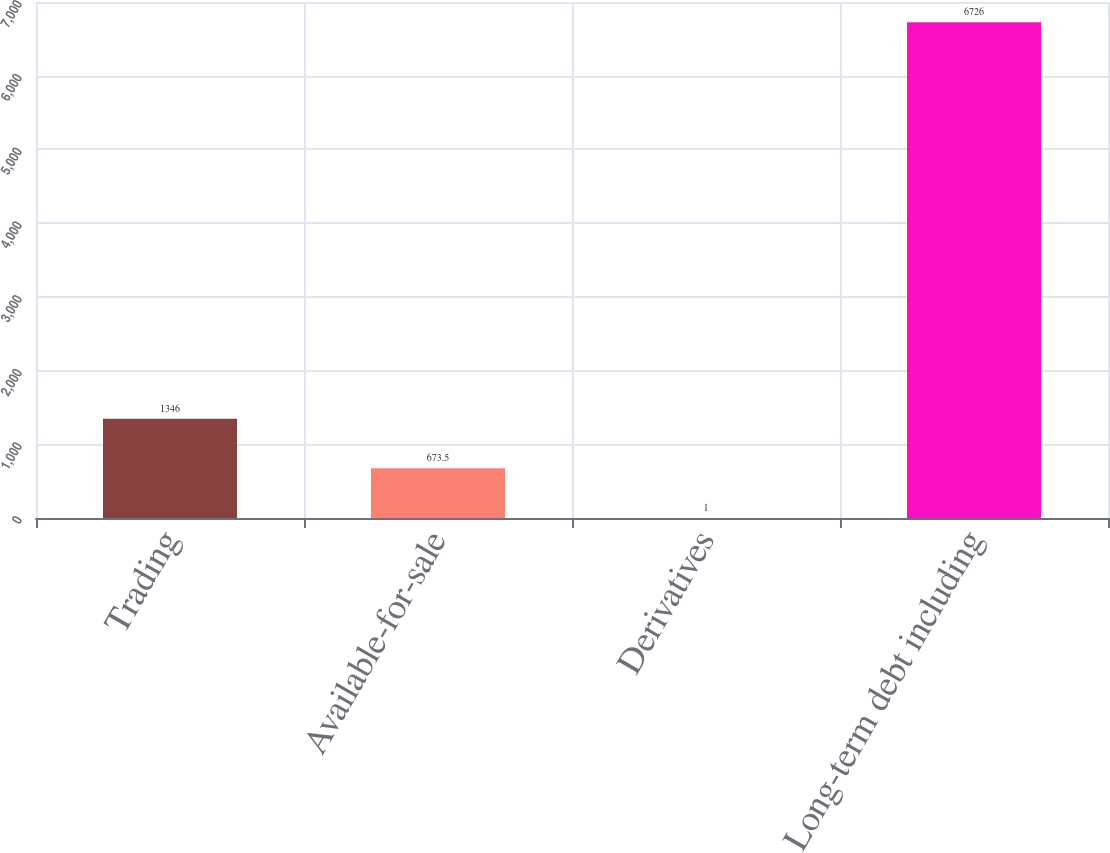Convert chart to OTSL. <chart><loc_0><loc_0><loc_500><loc_500><bar_chart><fcel>Trading<fcel>Available-for-sale<fcel>Derivatives<fcel>Long-term debt including<nl><fcel>1346<fcel>673.5<fcel>1<fcel>6726<nl></chart> 